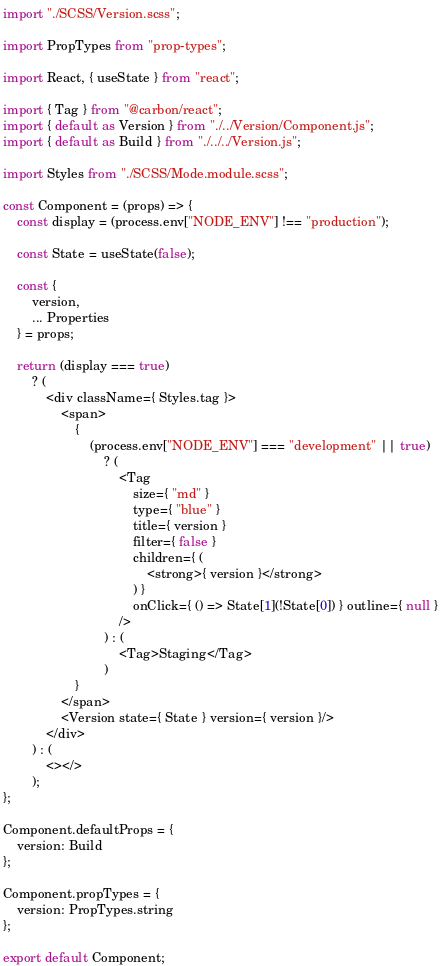Convert code to text. <code><loc_0><loc_0><loc_500><loc_500><_JavaScript_>import "./SCSS/Version.scss";

import PropTypes from "prop-types";

import React, { useState } from "react";

import { Tag } from "@carbon/react";
import { default as Version } from "./../Version/Component.js";
import { default as Build } from "./../../Version.js";

import Styles from "./SCSS/Mode.module.scss";

const Component = (props) => {
    const display = (process.env["NODE_ENV"] !== "production");

    const State = useState(false);

    const {
        version,
        ... Properties
    } = props;

    return (display === true)
        ? (
            <div className={ Styles.tag }>
                <span>
                    {
                        (process.env["NODE_ENV"] === "development" || true)
                            ? (
                                <Tag
                                    size={ "md" }
                                    type={ "blue" }
                                    title={ version }
                                    filter={ false }
                                    children={ (
                                        <strong>{ version }</strong>
                                    ) }
                                    onClick={ () => State[1](!State[0]) } outline={ null }
                                />
                            ) : (
                                <Tag>Staging</Tag>
                            )
                    }
                </span>
                <Version state={ State } version={ version }/>
            </div>
        ) : (
            <></>
        );
};

Component.defaultProps = {
    version: Build
};

Component.propTypes = {
    version: PropTypes.string
};

export default Component;
</code> 